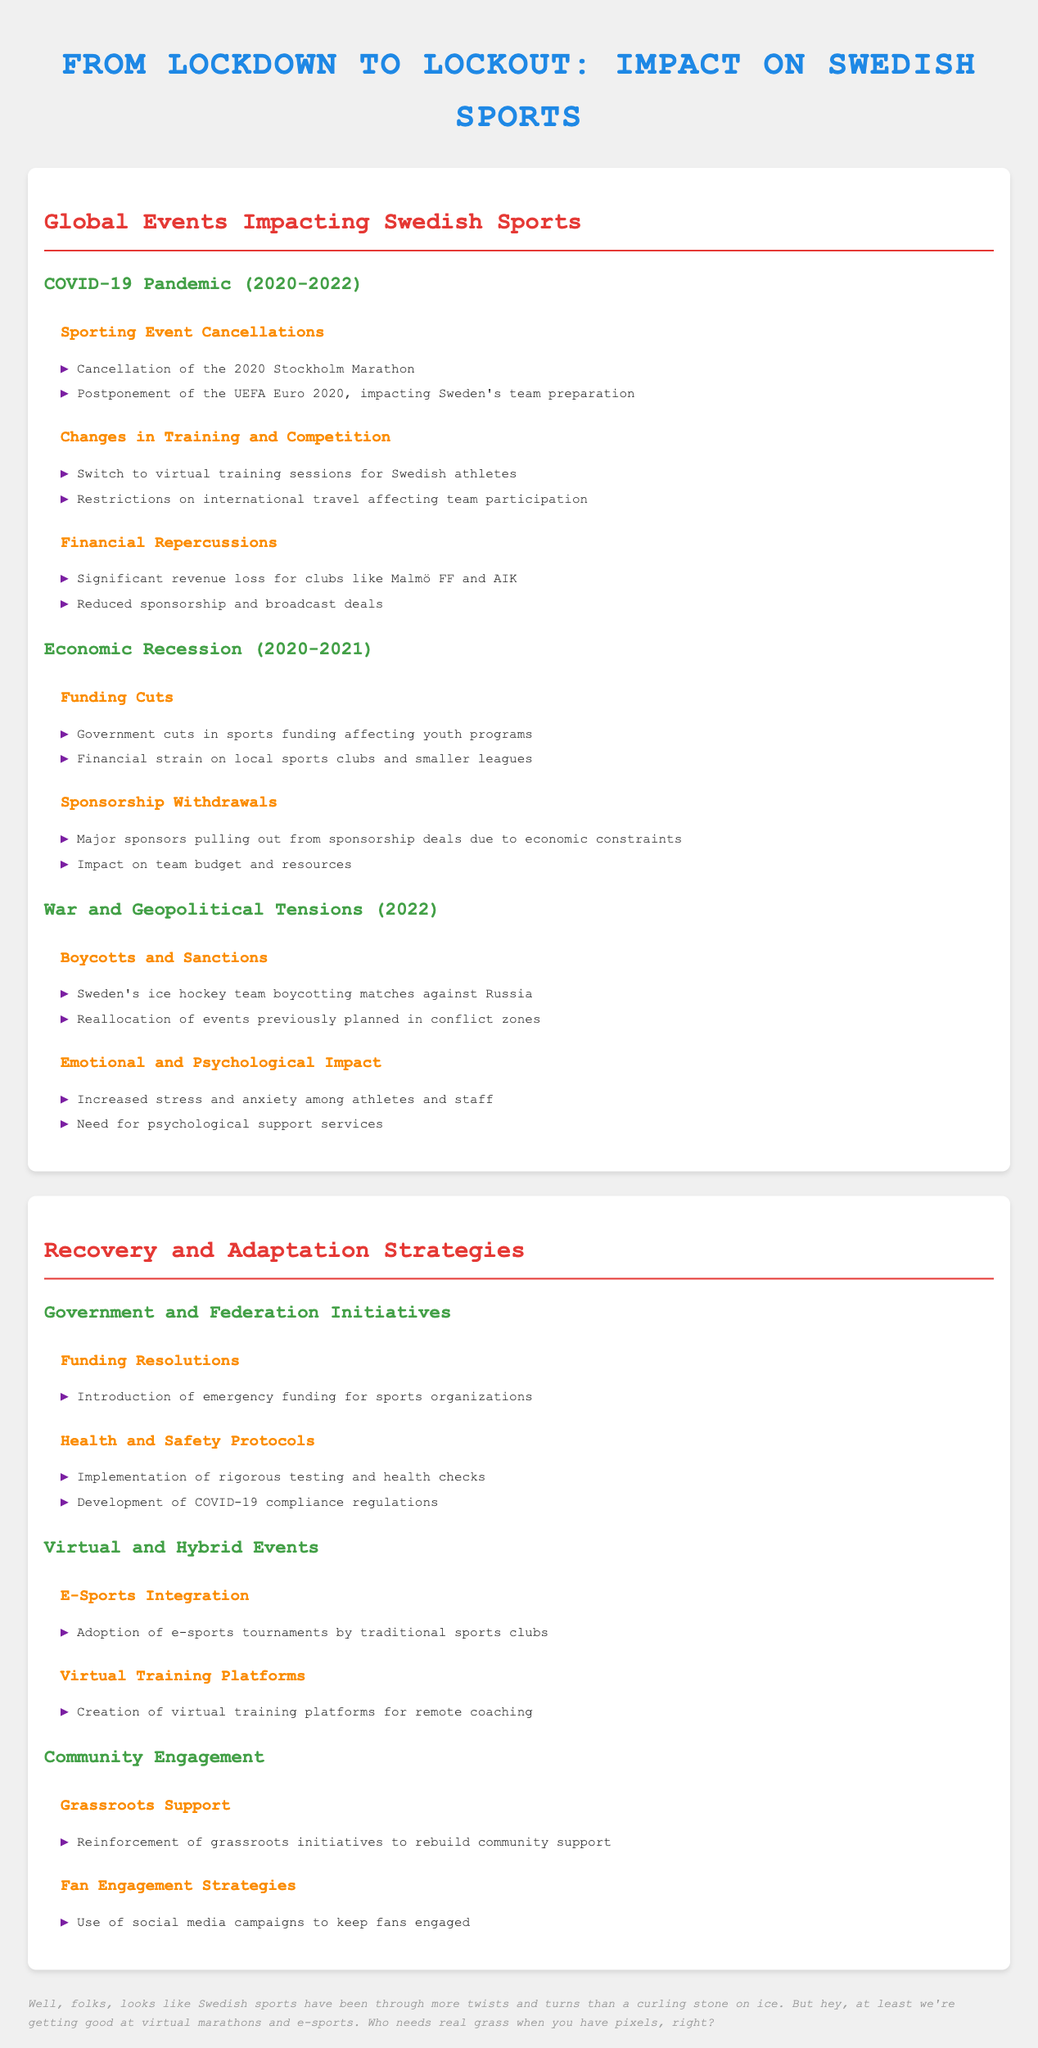What event was cancelled in 2020? The document states that the 2020 Stockholm Marathon was cancelled due to the pandemic.
Answer: 2020 Stockholm Marathon What financial consequence did Malmö FF face? The document mentions significant revenue loss for clubs like Malmö FF due to the pandemic.
Answer: Revenue loss What year did the economic recession occur? According to the document, the economic recession affecting sports in Sweden occurred in 2020-2021.
Answer: 2020-2021 Which team boycotted matches against Russia? The document specifies that Sweden's ice hockey team boycotted matches against Russia in 2022.
Answer: Sweden's ice hockey team What was introduced for sports organizations? The document highlights the introduction of emergency funding for sports organizations to support recovery.
Answer: Emergency funding How did traditional sports clubs adapt? The document states that traditional sports clubs adopted e-sports tournaments as part of their adaptation strategies.
Answer: E-sports tournaments What was a significant emotional consequence for athletes? The document notes increased stress and anxiety among athletes and staff due to various global events.
Answer: Increased stress What strategies were used for fan engagement? The document details the use of social media campaigns to engage fans.
Answer: Social media campaigns What type of training platform was created? The document mentions the creation of virtual training platforms for remote coaching as a strategy for adaptation.
Answer: Virtual training platforms 